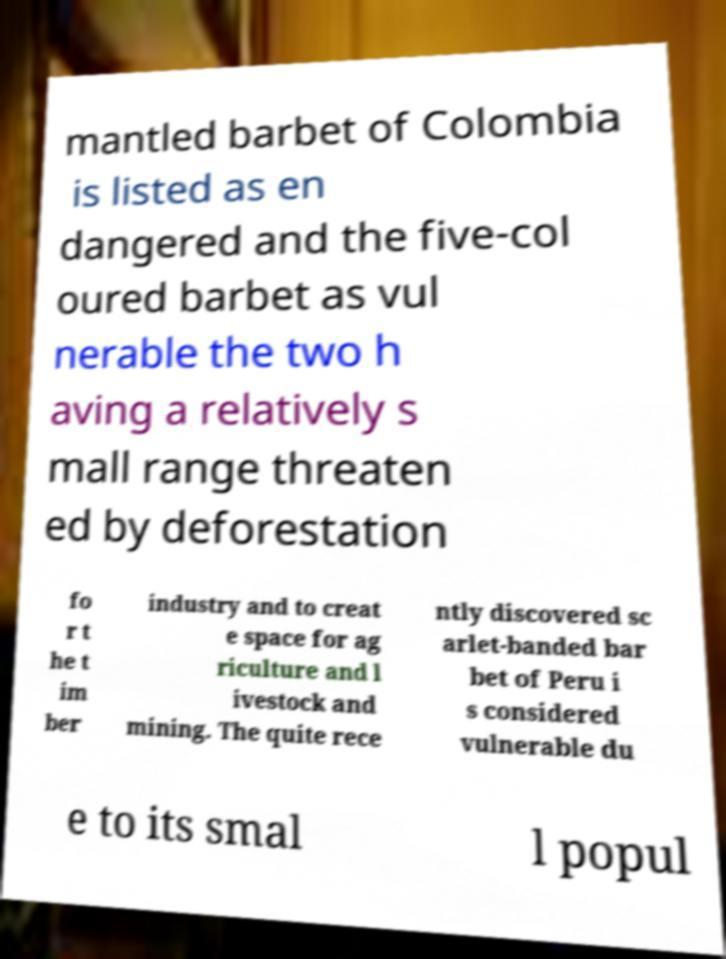Please identify and transcribe the text found in this image. mantled barbet of Colombia is listed as en dangered and the five-col oured barbet as vul nerable the two h aving a relatively s mall range threaten ed by deforestation fo r t he t im ber industry and to creat e space for ag riculture and l ivestock and mining. The quite rece ntly discovered sc arlet-banded bar bet of Peru i s considered vulnerable du e to its smal l popul 